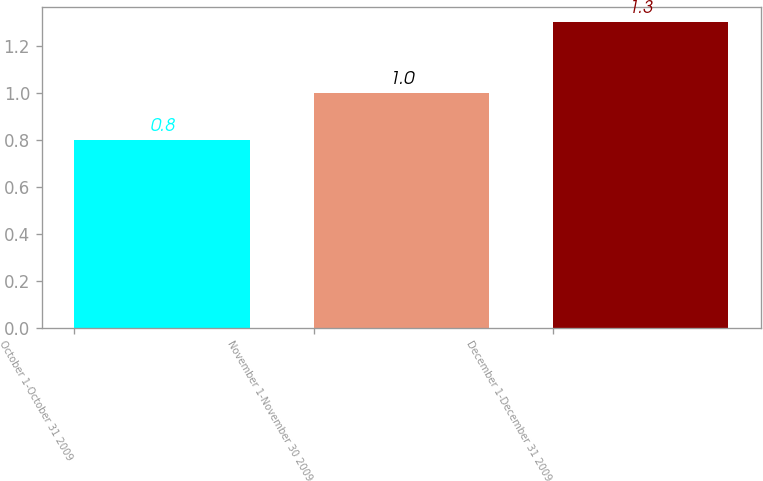Convert chart to OTSL. <chart><loc_0><loc_0><loc_500><loc_500><bar_chart><fcel>October 1-October 31 2009<fcel>November 1-November 30 2009<fcel>December 1-December 31 2009<nl><fcel>0.8<fcel>1<fcel>1.3<nl></chart> 